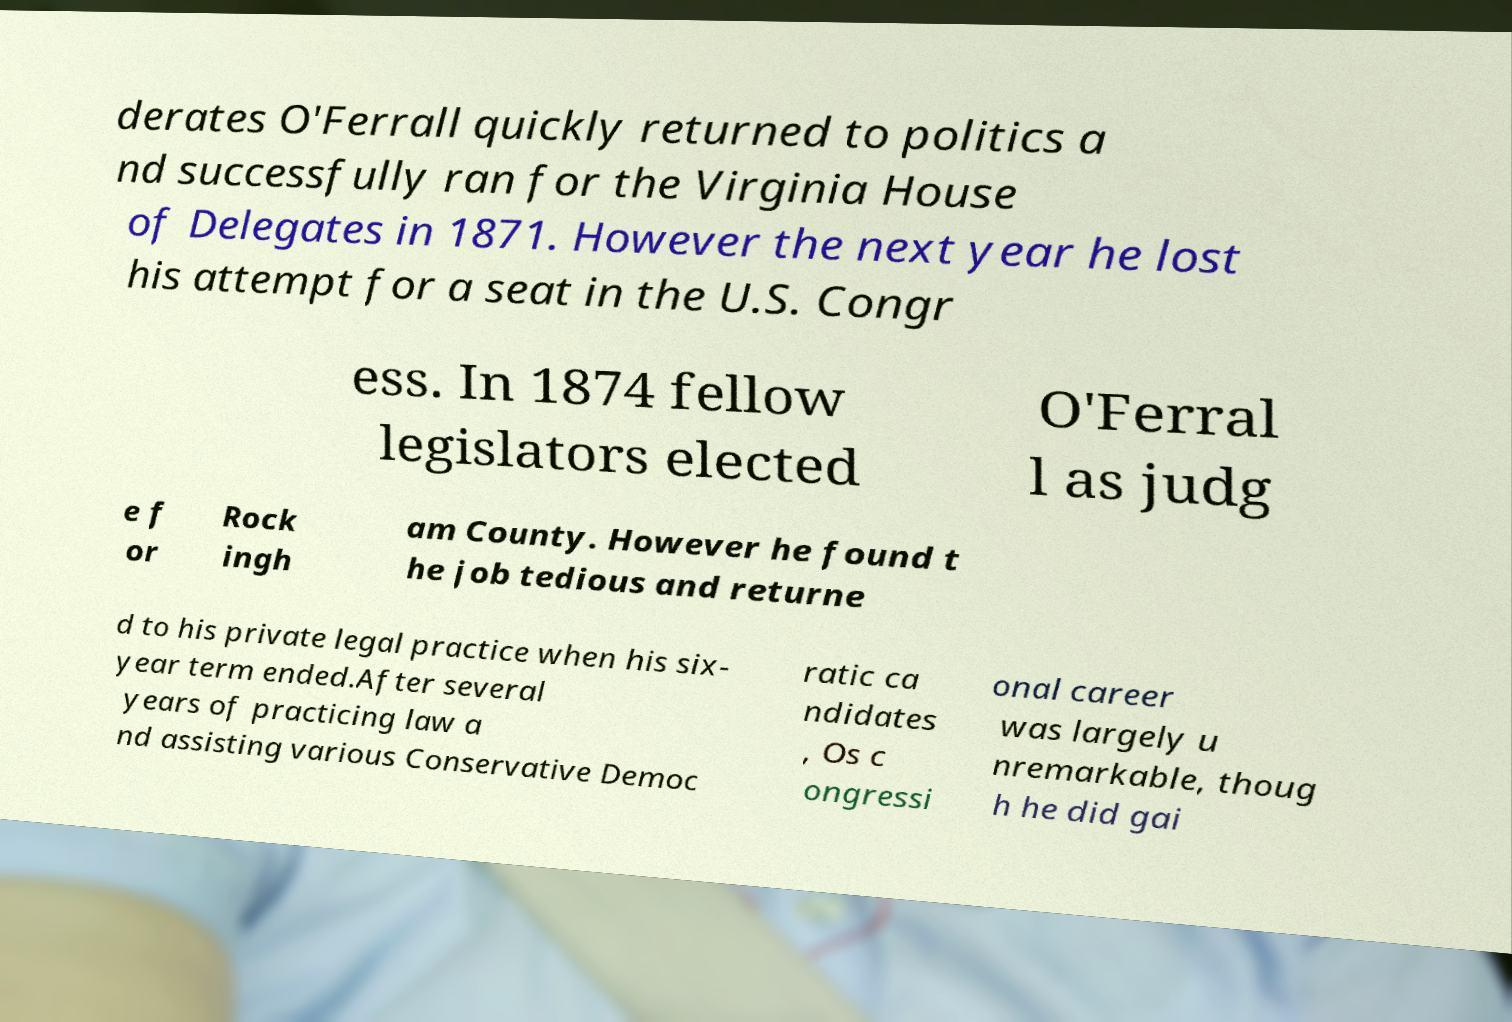I need the written content from this picture converted into text. Can you do that? derates O'Ferrall quickly returned to politics a nd successfully ran for the Virginia House of Delegates in 1871. However the next year he lost his attempt for a seat in the U.S. Congr ess. In 1874 fellow legislators elected O'Ferral l as judg e f or Rock ingh am County. However he found t he job tedious and returne d to his private legal practice when his six- year term ended.After several years of practicing law a nd assisting various Conservative Democ ratic ca ndidates , Os c ongressi onal career was largely u nremarkable, thoug h he did gai 